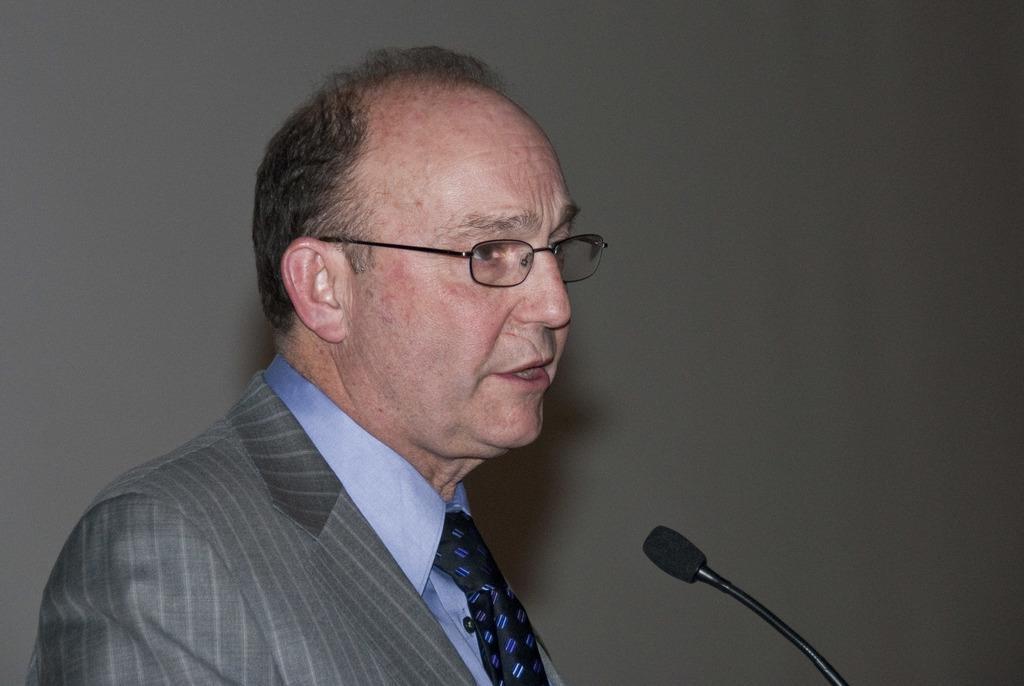Describe this image in one or two sentences. On the left side of the image we can see a man is wearing suit, tie, spectacles and talking. In-front of him we can see a mic with stand. In the background of the image we can see the wall. 